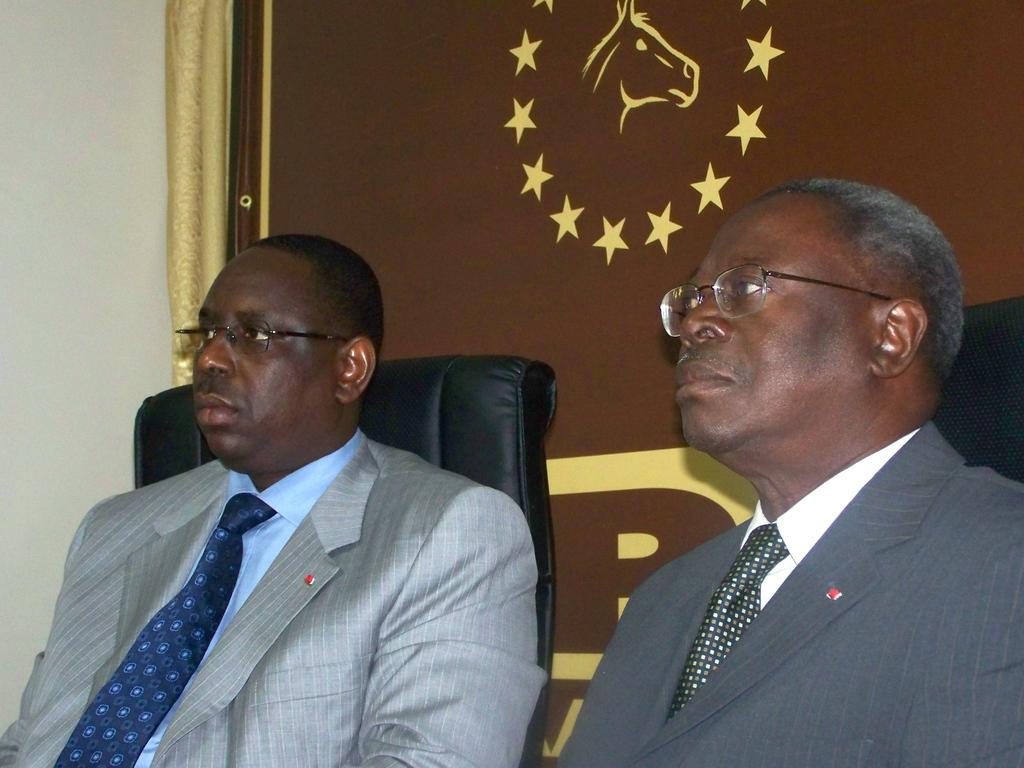How many people are in the image? There are two persons in the image. What are the persons doing in the image? The persons are sitting on chairs. What can be seen in the background of the image? There is a wall in the background of the image. What type of bait is being used by the persons in the image? There is no indication of fishing or bait in the image; the persons are simply sitting on chairs. 